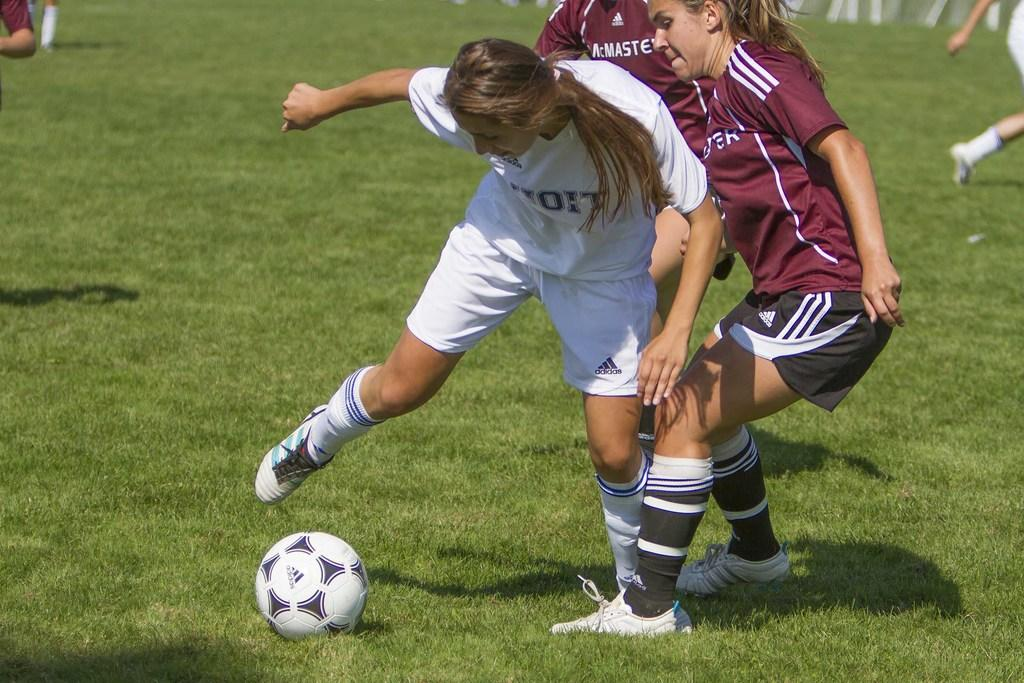What sport are the women playing in the image? The women are playing football in the image. What type of clothing are the women wearing while playing football? The women are wearing jerseys and shorts. What type of footwear are the women wearing? The women are wearing shoes. What type of surface is visible in the image? There is grass visible in the image. What is the main object used in the game of football? There is a football in the image. Can you see any umbrellas being used by the women in the image? There are no umbrellas visible in the image. What type of dust can be seen on the football in the image? There is no dust visible on the football in the image. 